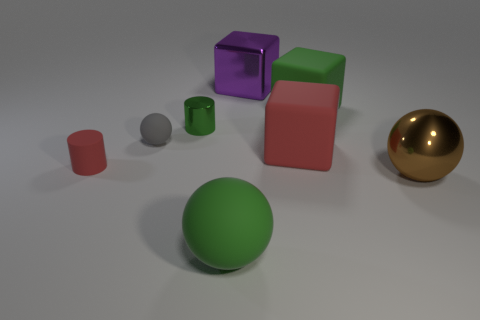There is a matte thing that is both to the left of the red matte cube and behind the tiny red rubber cylinder; how big is it?
Offer a terse response. Small. What number of other things are the same color as the rubber cylinder?
Provide a succinct answer. 1. Do the tiny red cylinder and the small cylinder that is right of the small rubber ball have the same material?
Your response must be concise. No. How many things are green things that are behind the red rubber cylinder or large red rubber blocks?
Give a very brief answer. 3. What shape is the matte thing that is on the left side of the purple shiny thing and to the right of the small ball?
Keep it short and to the point. Sphere. Are there any other things that are the same size as the gray thing?
Provide a short and direct response. Yes. What is the size of the green thing that is made of the same material as the large purple cube?
Your answer should be compact. Small. What number of things are either tiny objects to the right of the gray rubber sphere or cubes on the right side of the metal cube?
Make the answer very short. 3. Does the cube on the left side of the red cube have the same size as the tiny gray sphere?
Offer a very short reply. No. What is the color of the large sphere that is on the right side of the large green matte ball?
Make the answer very short. Brown. 